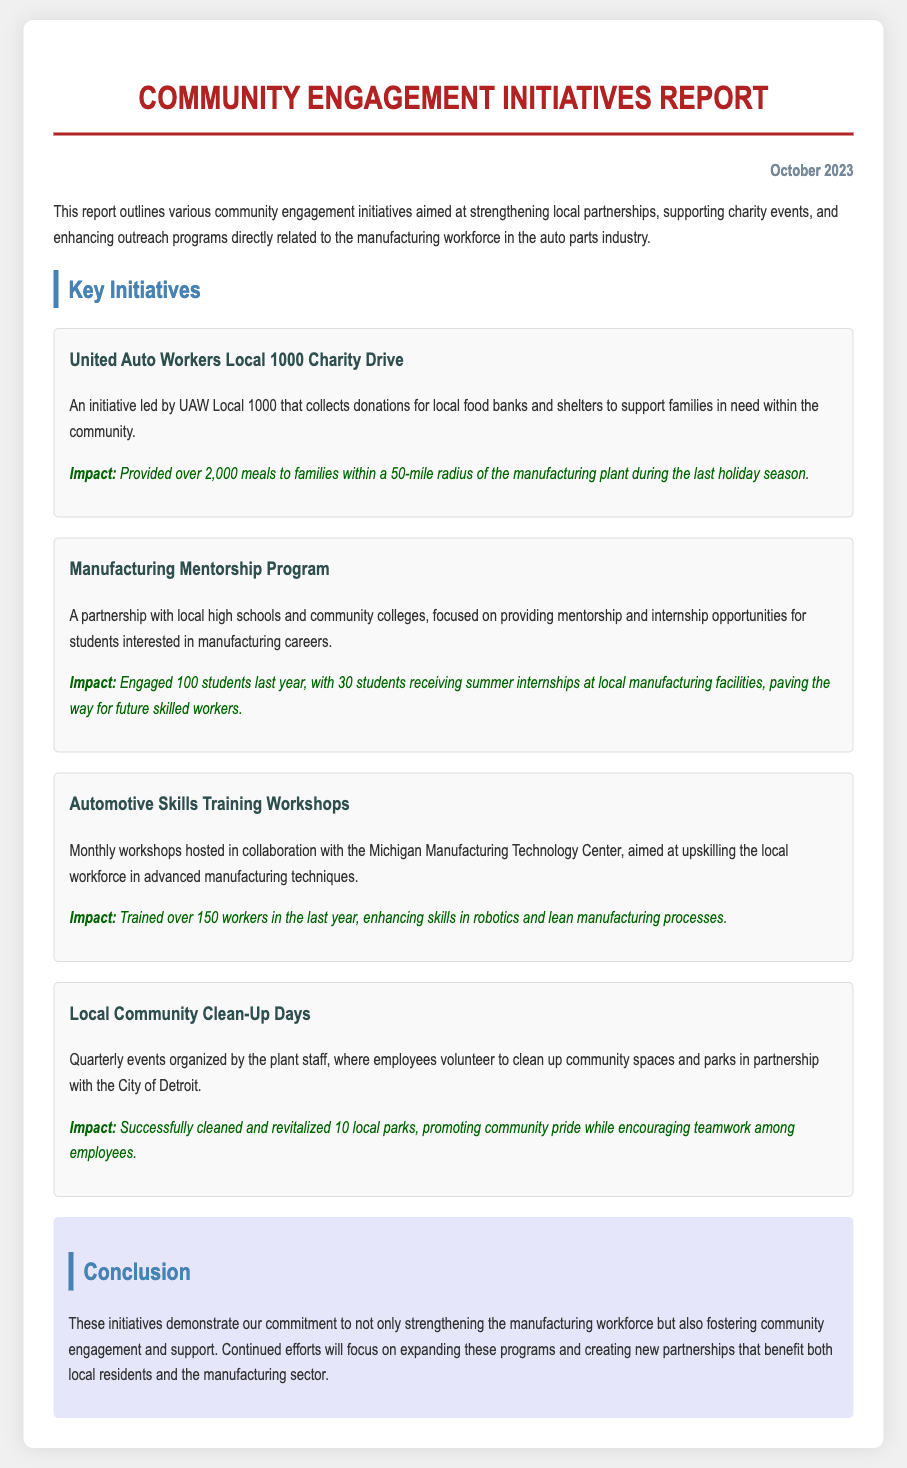What is the date of the report? The report is dated as indicated in the document.
Answer: October 2023 What charity is involved in the charity drive initiative? The document specifies the organization leading the charity drive initiative.
Answer: UAW Local 1000 How many meals were provided to families during the last holiday season? The report provides a specific number reflecting the impact of the charity drive.
Answer: Over 2,000 meals How many students engaged in the Manufacturing Mentorship Program last year? The document states the number of students involved in the program.
Answer: 100 students What is the partnership for the Automotive Skills Training Workshops? The report notes the organization working with the workshops.
Answer: Michigan Manufacturing Technology Center How many local parks were cleaned during the Community Clean-Up Days? The document mentions the number of parks revitalized through community efforts.
Answer: 10 local parks What is the primary focus of the Manufacturing Mentorship Program? The program is designed to provide specific opportunities for students as mentioned in the report.
Answer: Mentorship and internship opportunities What is the main aim of these community engagement initiatives? The report concludes with the overall purpose of the initiatives presented.
Answer: Strengthening the manufacturing workforce and fostering community engagement How many workers were trained in the past year through the Automotive Skills Training Workshops? The document specifies the number of workers who participated in training.
Answer: Over 150 workers 